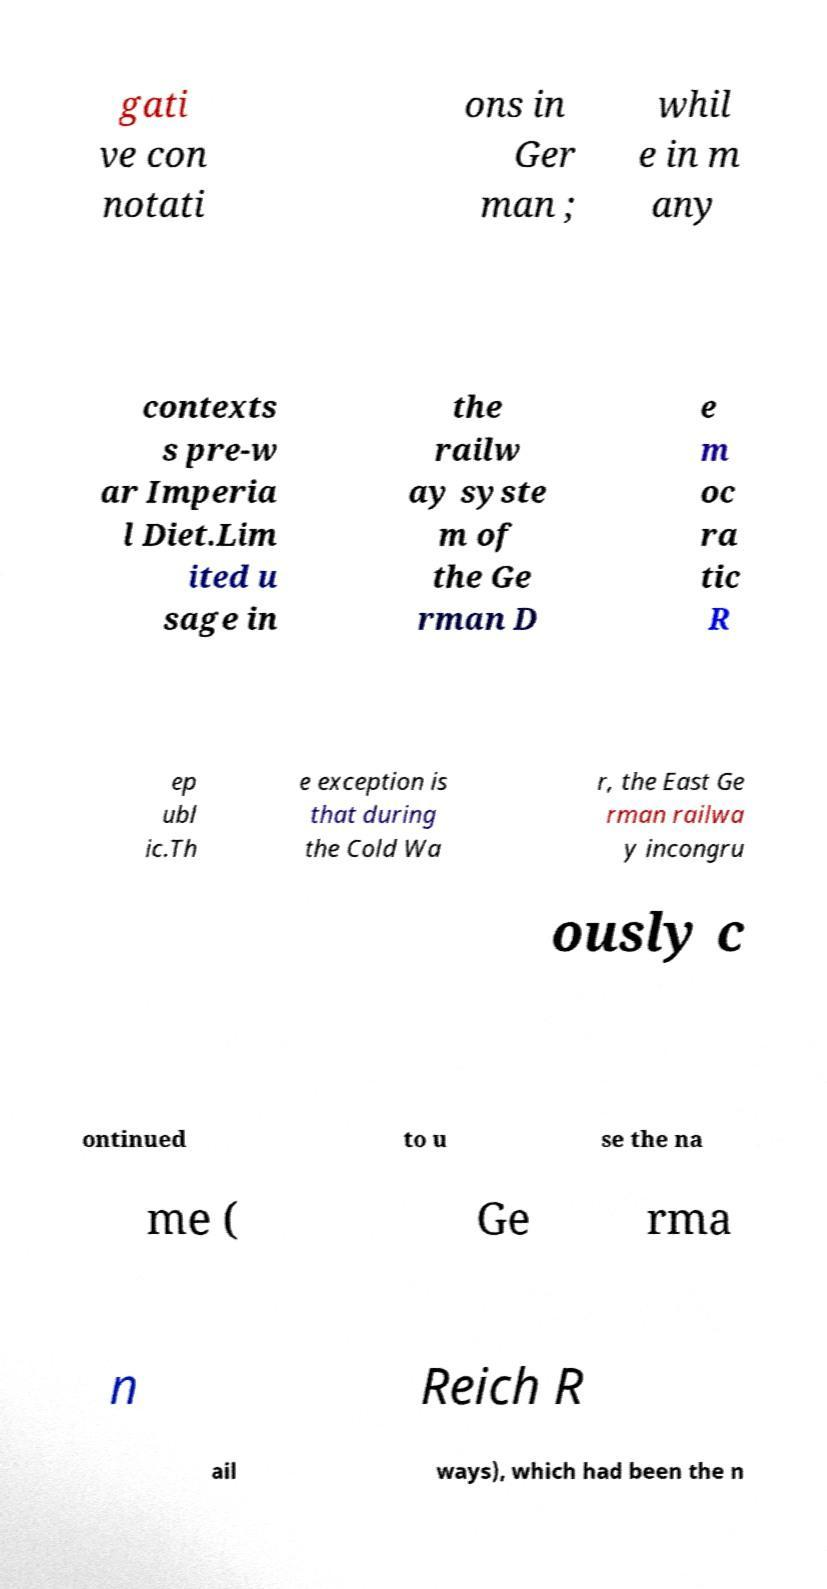Could you assist in decoding the text presented in this image and type it out clearly? gati ve con notati ons in Ger man ; whil e in m any contexts s pre-w ar Imperia l Diet.Lim ited u sage in the railw ay syste m of the Ge rman D e m oc ra tic R ep ubl ic.Th e exception is that during the Cold Wa r, the East Ge rman railwa y incongru ously c ontinued to u se the na me ( Ge rma n Reich R ail ways), which had been the n 